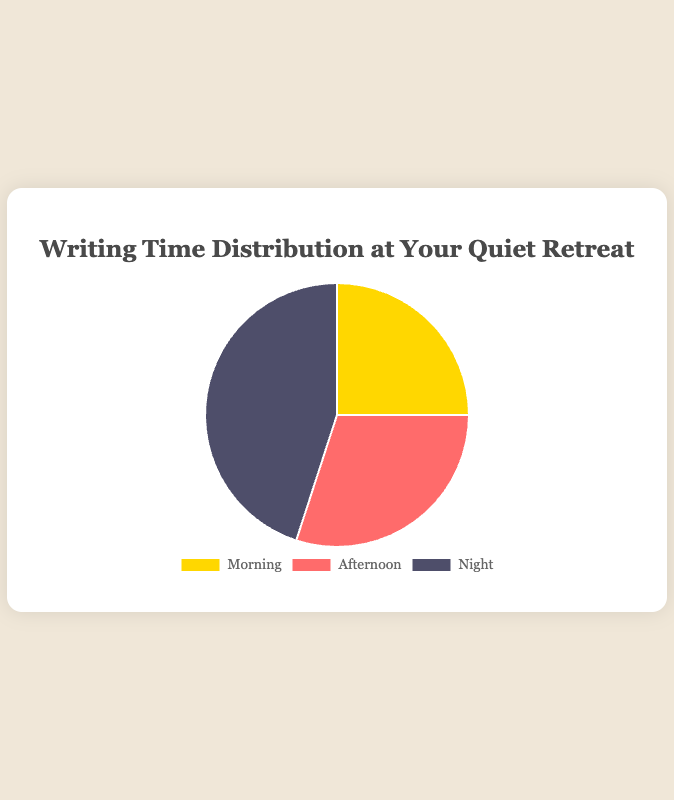What is the total time spent writing in a day? To find the total time, sum up the hours spent in the Morning (2.5), Afternoon (3), and Night (4.5). The sum is 2.5 + 3 + 4.5 = 10 hours.
Answer: 10 hours Which time period has the highest number of writing hours? The time periods are Morning with 2.5 hours, Afternoon with 3 hours, and Night with 4.5 hours. Night has the highest number of writing hours.
Answer: Night How many more hours are spent writing at Night compared to Morning? Subtract the Morning hours (2.5) from the Night hours (4.5). The difference is 4.5 - 2.5 = 2 hours.
Answer: 2 hours What percentage of the total writing time is spent in the Afternoon? First, find the total hours spent writing, which is 10 hours. Then, calculate the percentage for the Afternoon (3 hours) by (3 / 10) * 100. The result is 30%.
Answer: 30% Which time period has the least number of writing hours? The time periods are Morning with 2.5 hours, Afternoon with 3 hours, and Night with 4.5 hours. Morning has the least number of writing hours.
Answer: Morning Do the combined writing hours of Morning and Afternoon surpass the writing hours at Night? Sum the Morning (2.5) and Afternoon (3) hours, which equals 2.5 + 3 = 5. Compare it to Night hours (4.5). 5 is greater than 4.5, so yes.
Answer: Yes What is the average amount of writing time per time period? To find the average, divide the total hours (10) by the number of time periods (3). The average is 10 / 3 ≈ 3.33 hours.
Answer: 3.33 hours Which time period is represented with yellow color in the pie chart? The colors used in the chart are yellow for Morning, red for Afternoon, and blue for Night. The Morning time period is represented with yellow.
Answer: Morning 